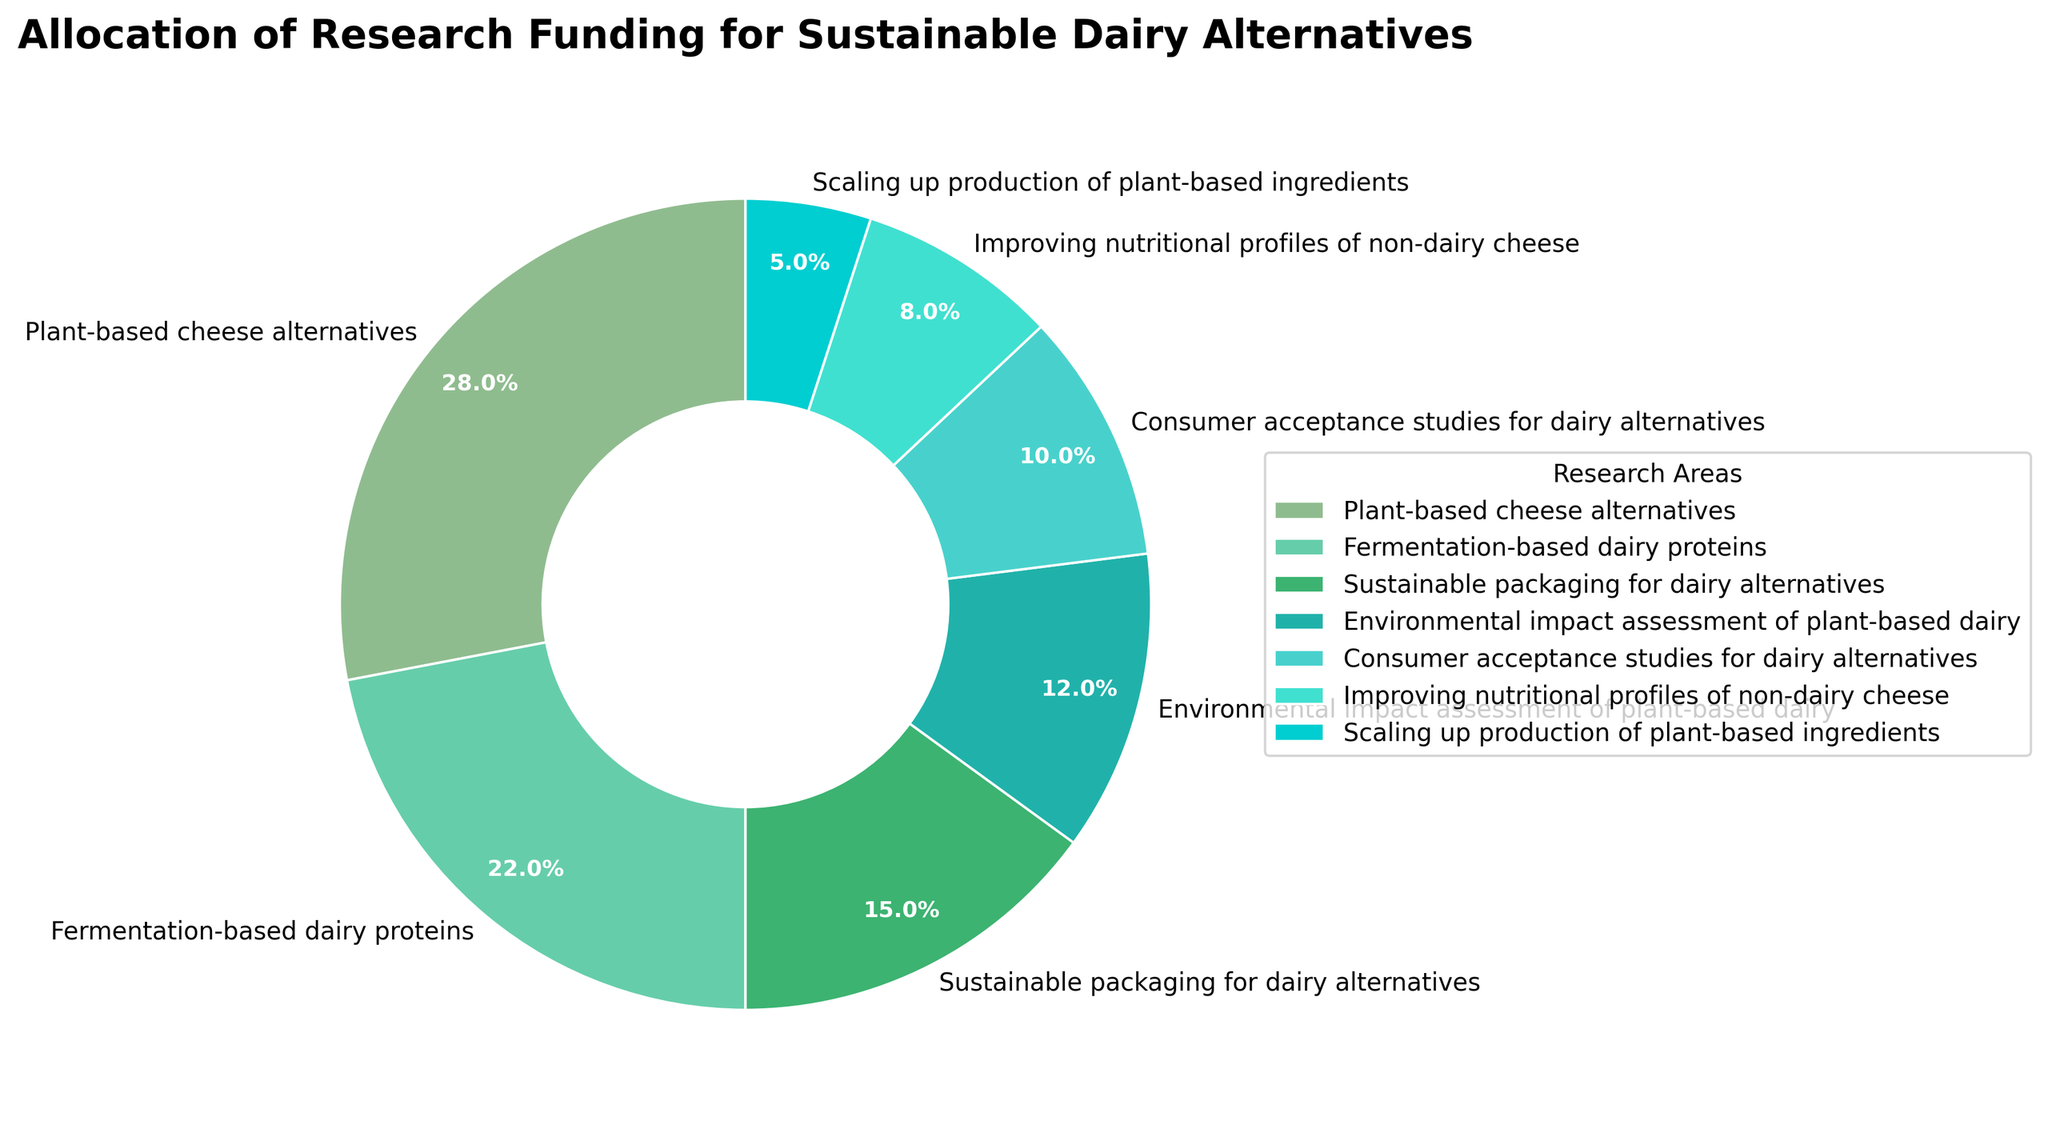What is the allocation percentage for plant-based cheese alternatives? The "Plant-based cheese alternatives" segment is labeled directly in the pie chart with its associated percentage.
Answer: 28% Which research area received the least funding? Examine the pie chart sections to identify the smallest segment, which corresponds to the area with the least allocation.
Answer: Scaling up production of plant-based ingredients How much more funding is allocated to fermentation-based dairy proteins compared to consumer acceptance studies for dairy alternatives? Fermentation-based dairy proteins have 22% of the funding, while consumer acceptance studies have 10%. The difference is calculated as 22% - 10%.
Answer: 12% What's the sum of funding percentages allocated to plant-based cheese alternatives and environmental impact assessment of plant-based dairy? Add the percentages from the "Plant-based cheese alternatives" (28%) and "Environmental impact assessment of plant-based dairy" (12%) segments.
Answer: 40% Which category has a larger allocation: sustainable packaging for dairy alternatives or improving nutritional profiles of non-dairy cheese? Compare the percentages labeled in the respective segments; "Sustainable packaging for dairy alternatives" is 15%, and "Improving nutritional profiles of non-dairy cheese" is 8%.
Answer: Sustainable packaging for dairy alternatives What is the combined funding allocation for consumer acceptance studies and scaling up production of plant-based ingredients? Add the percentages from the "Consumer acceptance studies for dairy alternatives" (10%) and "Scaling up production of plant-based ingredients" (5%) segments.
Answer: 15% How does the percentage allocated to sustainable packaging for dairy alternatives compare to that of environmental impact assessment of plant-based dairy? Compare the percentages directly from the chart. "Sustainable packaging for dairy alternatives" has 15%, and "Environmental impact assessment of plant-based dairy" has 12%.
Answer: Greater Is the funding allocated to sustainable packaging for dairy alternatives greater than the total allocation for improving nutritional profiles of non-dairy cheese and scaling up production of plant-based ingredients combined? Add up the percentages for "Improving nutritional profiles of non-dairy cheese" (8%) and "Scaling up production of plant-based ingredients" (5%). Compare the sum (8% + 5% = 13%) to the percentage for "Sustainable packaging for dairy alternatives" (15%).
Answer: Yes What funding category is represented by the darkest green shade in the pie chart? By observing the colors in the pie chart, the darkest green shade corresponds to the largest segment, which is "Plant-based cheese alternatives" at 28%.
Answer: Plant-based cheese alternatives 